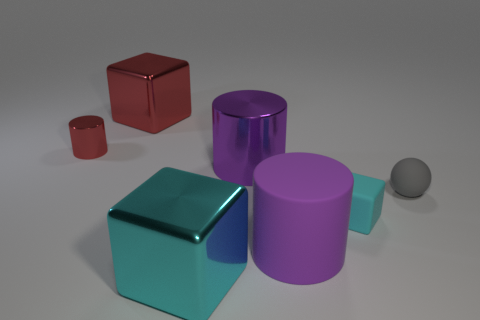How many things are red blocks or large cyan things?
Offer a terse response. 2. What shape is the big object that is to the left of the purple metal cylinder and behind the cyan matte cube?
Provide a short and direct response. Cube. There is a cyan metallic thing; is it the same shape as the thing that is right of the tiny cyan rubber cube?
Offer a very short reply. No. There is a tiny cylinder; are there any big shiny blocks behind it?
Provide a succinct answer. Yes. There is another block that is the same color as the rubber cube; what is its material?
Your answer should be very brief. Metal. What number of cubes are cyan metal things or tiny cyan rubber things?
Offer a very short reply. 2. Is the shape of the cyan rubber thing the same as the large red metallic thing?
Provide a succinct answer. Yes. What is the size of the matte thing that is in front of the cyan rubber block?
Offer a terse response. Large. Are there any metal blocks that have the same color as the tiny shiny cylinder?
Your answer should be compact. Yes. Do the metal block that is on the right side of the red cube and the cyan matte cube have the same size?
Your response must be concise. No. 